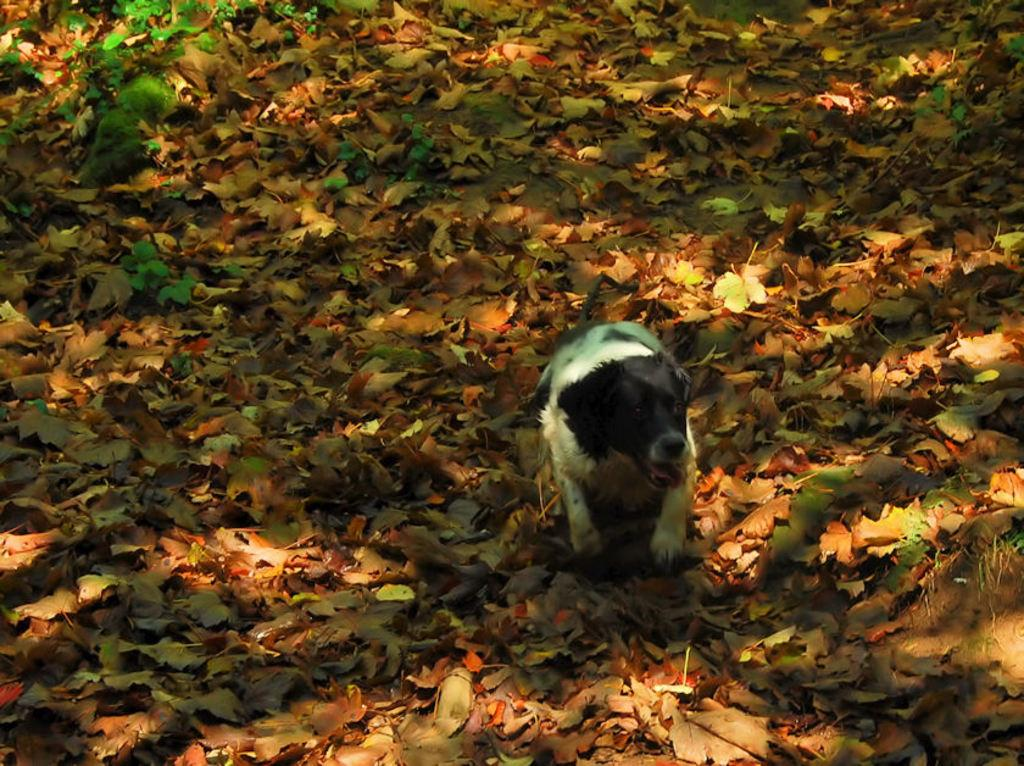What animal can be seen in the image? There is a dog in the image. Where is the dog located? The dog is on a path. What can be found on the path? There are dry leaves on the path. What type of brass instrument is the dog playing in the image? There is no brass instrument present in the image; it features a dog on a path with dry leaves. 